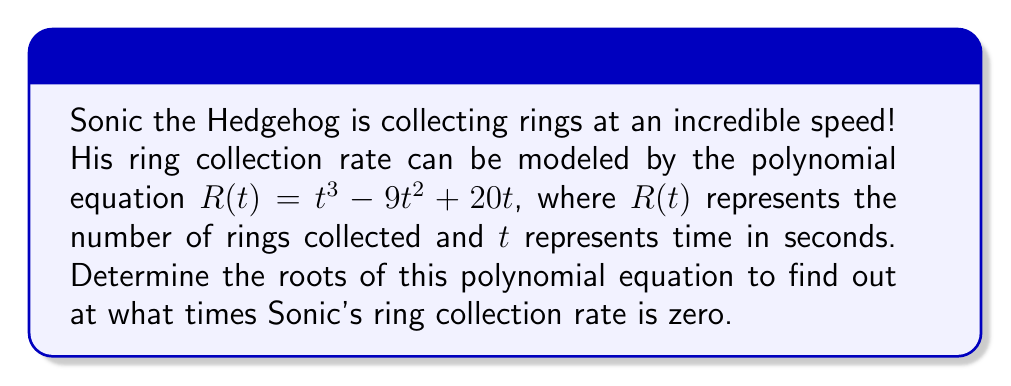Solve this math problem. Let's solve this step-by-step:

1) First, we need to factor out the greatest common factor (GCF):
   $R(t) = t^3 - 9t^2 + 20t$
   $R(t) = t(t^2 - 9t + 20)$

2) We can see that $t=0$ is one root of the equation.

3) Now, let's focus on the quadratic factor $(t^2 - 9t + 20)$:
   We can solve this using the quadratic formula: $t = \frac{-b \pm \sqrt{b^2 - 4ac}}{2a}$

   Where $a=1$, $b=-9$, and $c=20$

4) Substituting into the quadratic formula:
   $t = \frac{9 \pm \sqrt{(-9)^2 - 4(1)(20)}}{2(1)}$
   $t = \frac{9 \pm \sqrt{81 - 80}}{2}$
   $t = \frac{9 \pm \sqrt{1}}{2}$
   $t = \frac{9 \pm 1}{2}$

5) This gives us two more roots:
   $t = \frac{9 + 1}{2} = 5$ and $t = \frac{9 - 1}{2} = 4$

Therefore, the roots of the polynomial equation are $t = 0$, $t = 4$, and $t = 5$.
Answer: $t = 0$, $4$, $5$ 